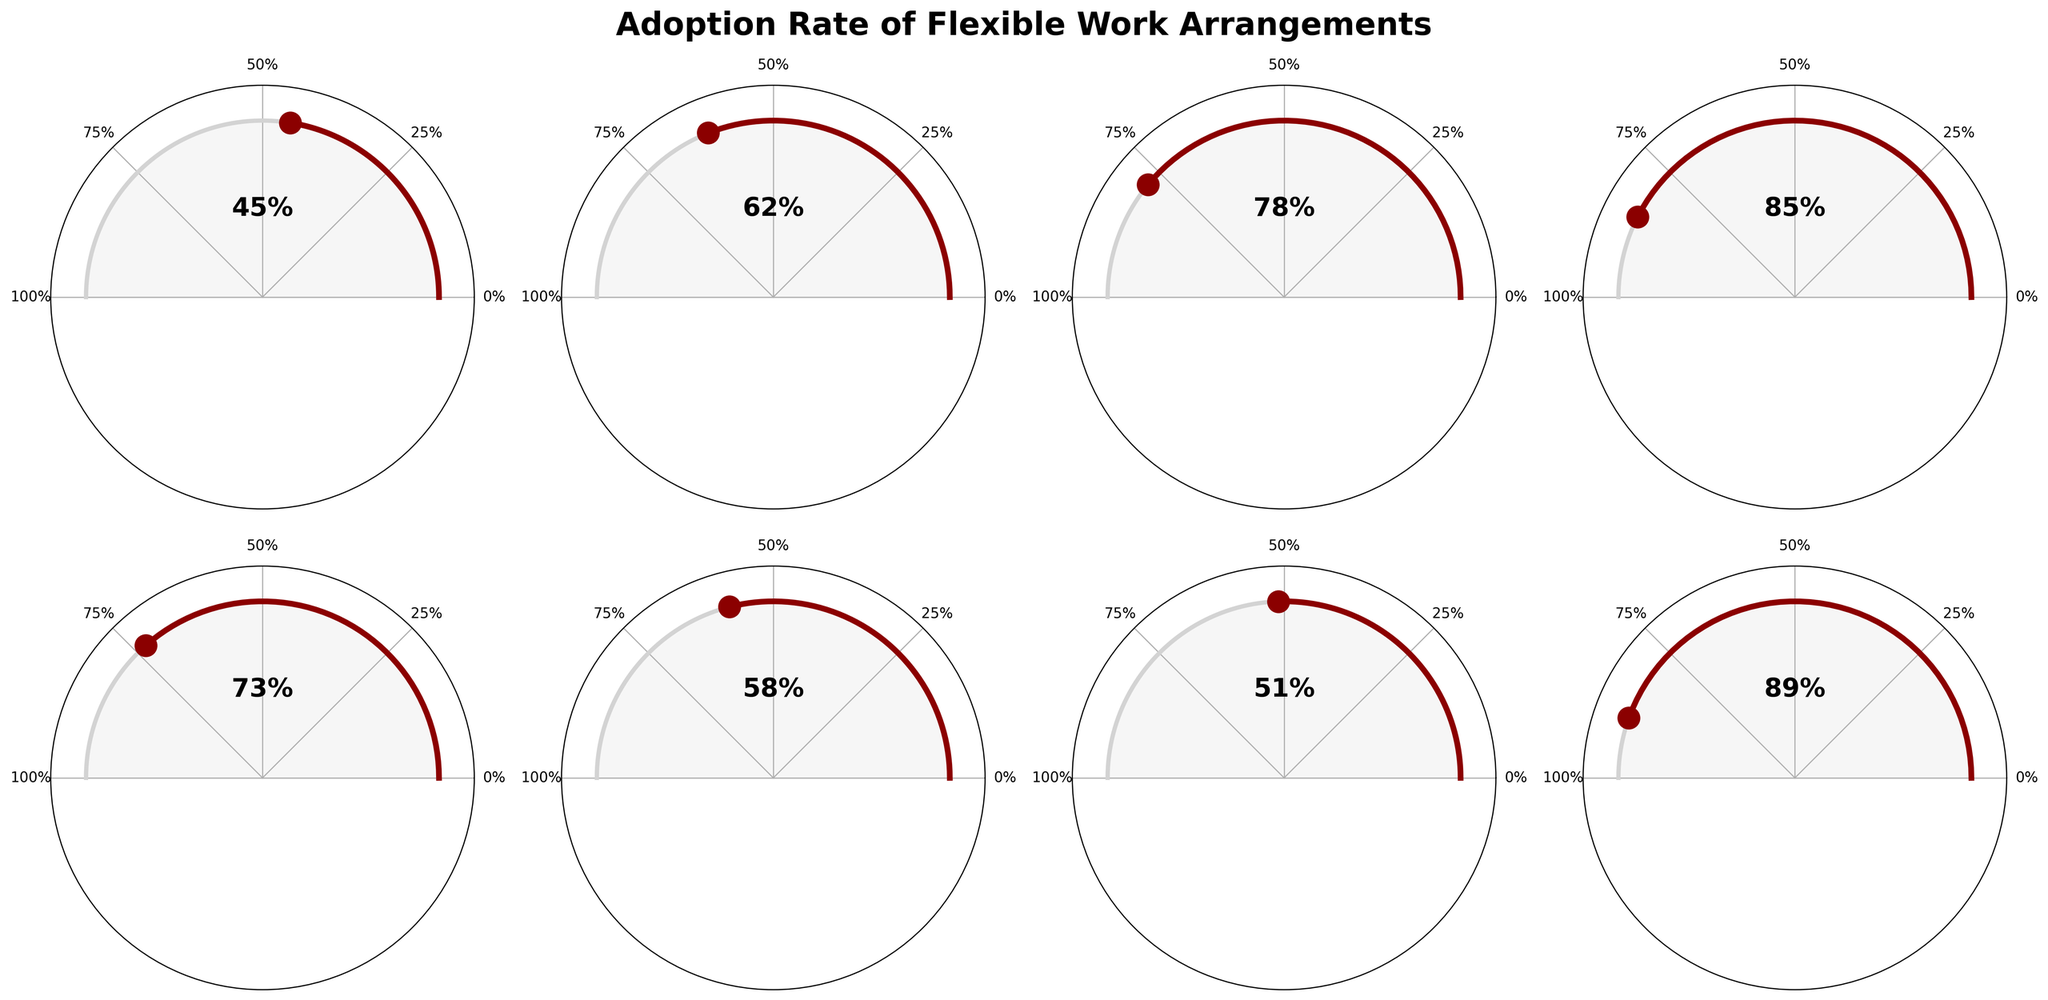What's the adoption rate of flexible work arrangements among Corporations (1000+ employees)? The visual shows that Corporations (1000+ employees) have a specific segment where the adoption rate is marked at 85%.
Answer: 85% Among Government Agencies and Non-Profit Organizations, which has a higher adoption rate? The gauge charts indicate that Government Agencies have a 58% adoption rate, while Non-Profit Organizations have a 51% rate. Therefore, Government Agencies have a higher adoption rate.
Answer: Government Agencies What is the range of adoption rates across all company sizes? The smallest adoption rate observed is for Small Businesses at 45%, and the highest is for Tech Startups at 89%. Thus, the range is 89 - 45 = 44%.
Answer: 44% Which company size shows the highest adoption rate of flexible work arrangements? Among all gauges, Tech Startups have the highest adoption rate at 89%.
Answer: Tech Startups Calculate the average adoption rate for all groups represented in the figure. Summing the adoption rates (45+62+78+85+73+58+51+89) gives 541. Dividing by the number of groups, 8, gives an average of 67.625%.
Answer: 67.625% What is the median adoption rate? Ordering the adoption rates (45, 51, 58, 62, 73, 78, 85, 89) and selecting the middle values (62 and 73), the median is the average of these two values: (62 + 73) / 2 = 67.5%.
Answer: 67.5% Which group has a similar adoption rate to Legal Firms? Legal Firms have an adoption rate of 73%. The closest group is Large Companies with an adoption rate of 78%, showing some similarity.
Answer: Large Companies Which type of companies have an adoption rate of greater than 80%? The gauge charts indicate that Tech Startups (89%) and Corporations (85%) exceed an 80% adoption rate.
Answer: Tech Startups, Corporations Between Medium Enterprises and Non-Profit Organizations, what is the difference in their adoption rates? Medium Enterprises have an adoption rate of 62%, while Non-Profit Organizations have a rate of 51%. The difference is 62 - 51 = 11%.
Answer: 11% How does the adoption rate of Small Businesses compare to the overall average adoption rate? Small Businesses have an adoption rate of 45%. The average adoption rate calculated previously is 67.625%. Small Businesses are below this average by 67.625 - 45 = 22.625%.
Answer: Below by 22.625% 